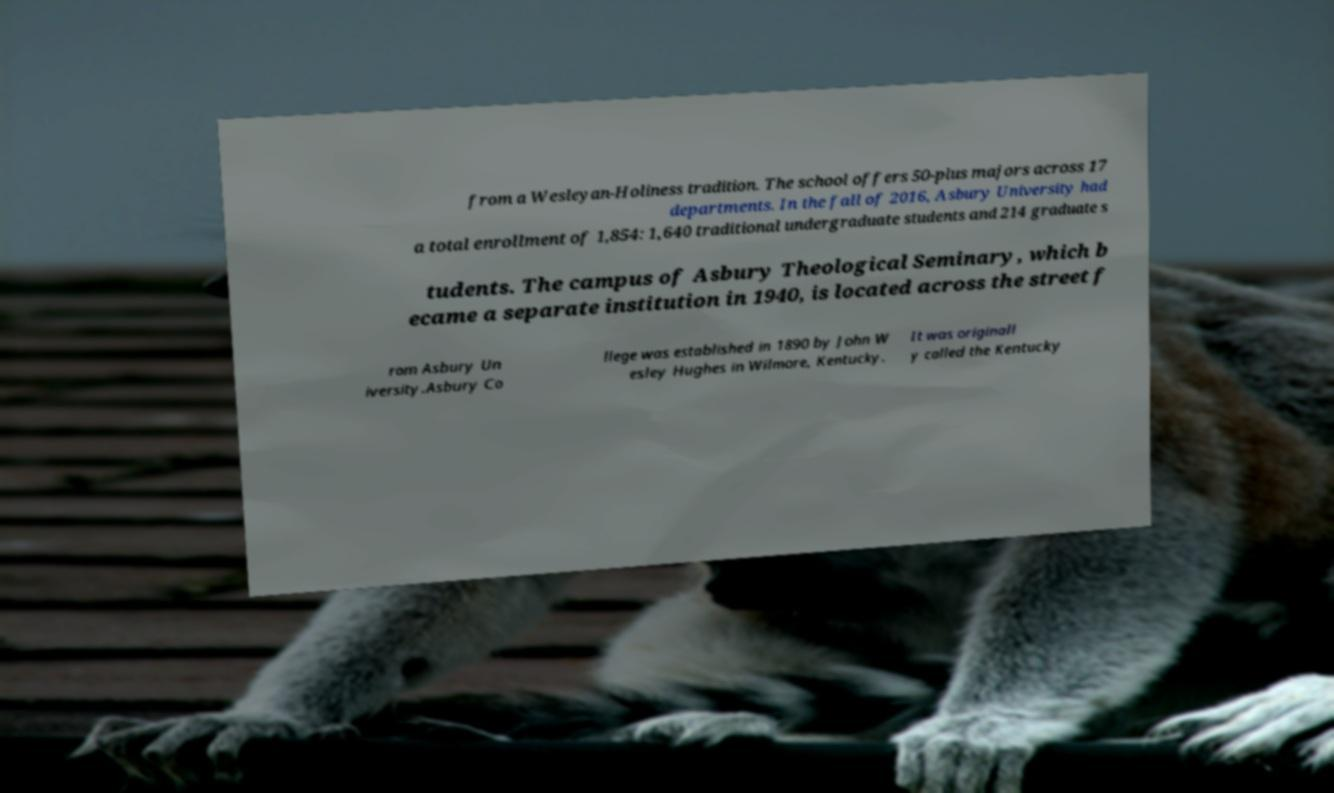Please identify and transcribe the text found in this image. from a Wesleyan-Holiness tradition. The school offers 50-plus majors across 17 departments. In the fall of 2016, Asbury University had a total enrollment of 1,854: 1,640 traditional undergraduate students and 214 graduate s tudents. The campus of Asbury Theological Seminary, which b ecame a separate institution in 1940, is located across the street f rom Asbury Un iversity.Asbury Co llege was established in 1890 by John W esley Hughes in Wilmore, Kentucky. It was originall y called the Kentucky 